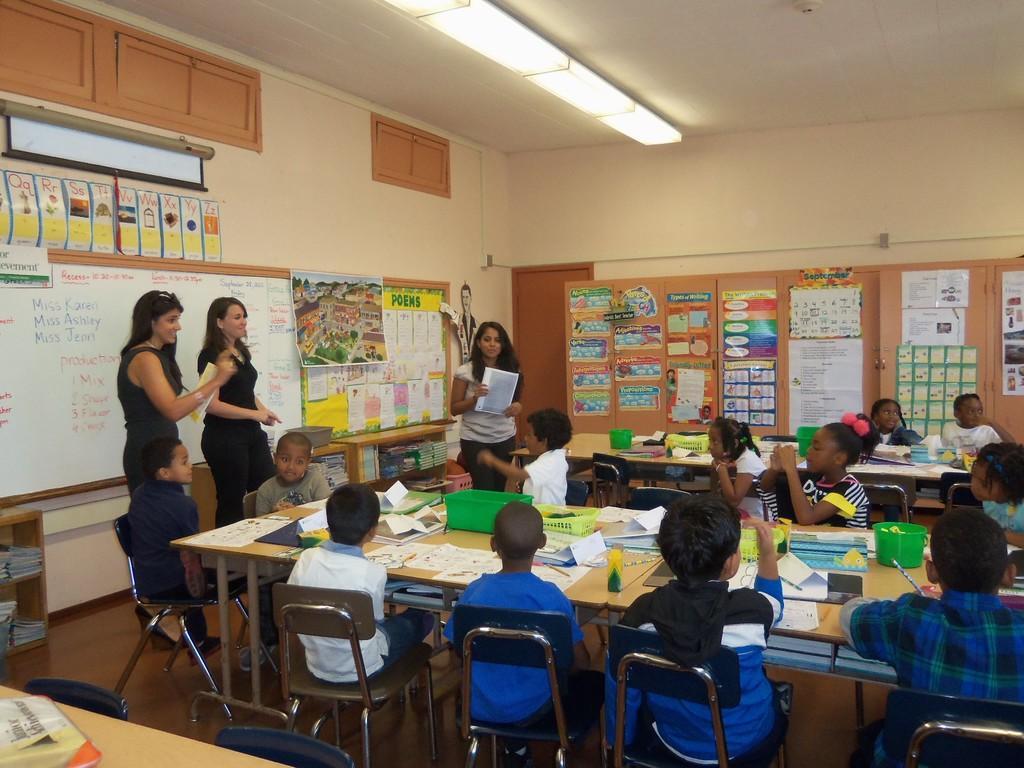Can you describe this image briefly? Group of children sitting on the chairs and these three persons are standing,these two persons are holding papers. We can see papers,baskets,toys,pencil on the tables. On the background we can see wall,boards,posters. On the top we can see lights. This is floor. 